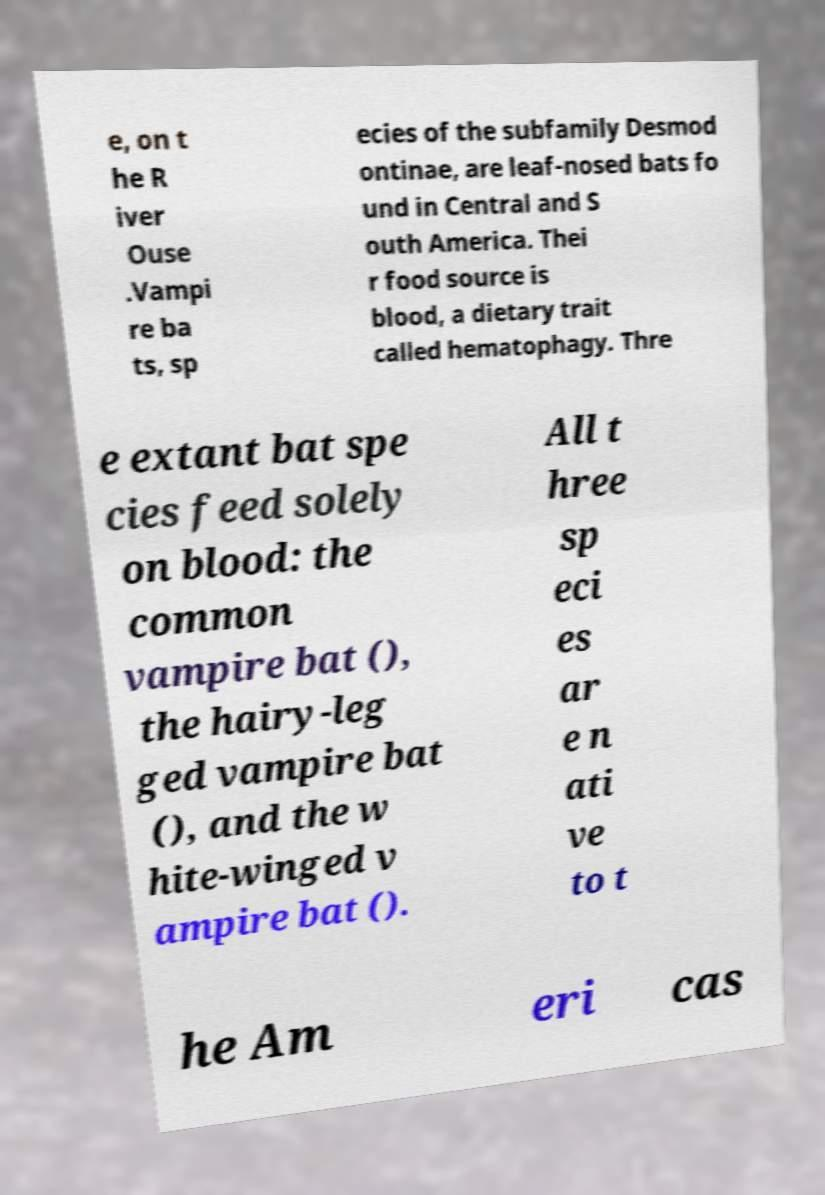Please identify and transcribe the text found in this image. e, on t he R iver Ouse .Vampi re ba ts, sp ecies of the subfamily Desmod ontinae, are leaf-nosed bats fo und in Central and S outh America. Thei r food source is blood, a dietary trait called hematophagy. Thre e extant bat spe cies feed solely on blood: the common vampire bat (), the hairy-leg ged vampire bat (), and the w hite-winged v ampire bat (). All t hree sp eci es ar e n ati ve to t he Am eri cas 